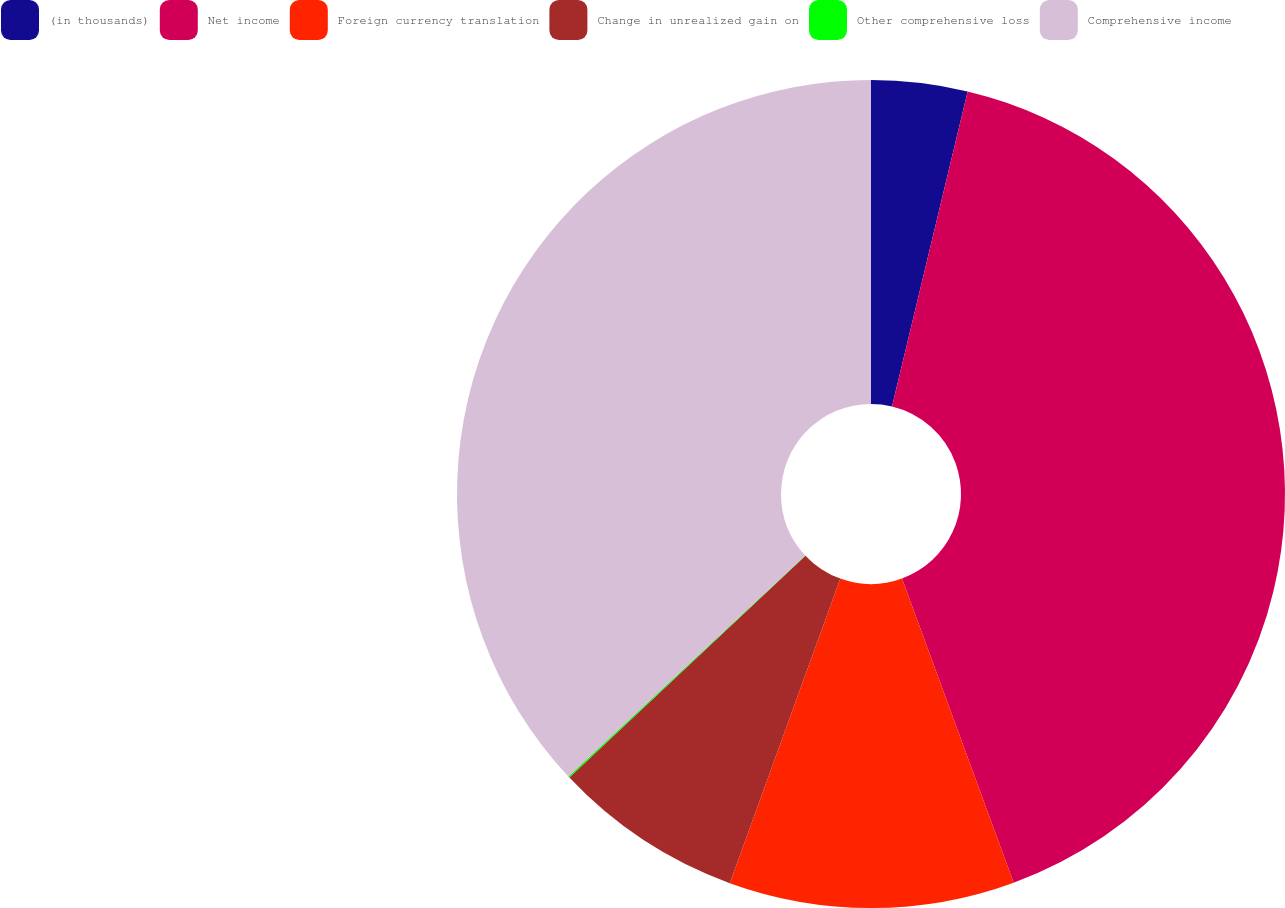<chart> <loc_0><loc_0><loc_500><loc_500><pie_chart><fcel>(in thousands)<fcel>Net income<fcel>Foreign currency translation<fcel>Change in unrealized gain on<fcel>Other comprehensive loss<fcel>Comprehensive income<nl><fcel>3.75%<fcel>40.65%<fcel>11.14%<fcel>7.45%<fcel>0.06%<fcel>36.95%<nl></chart> 